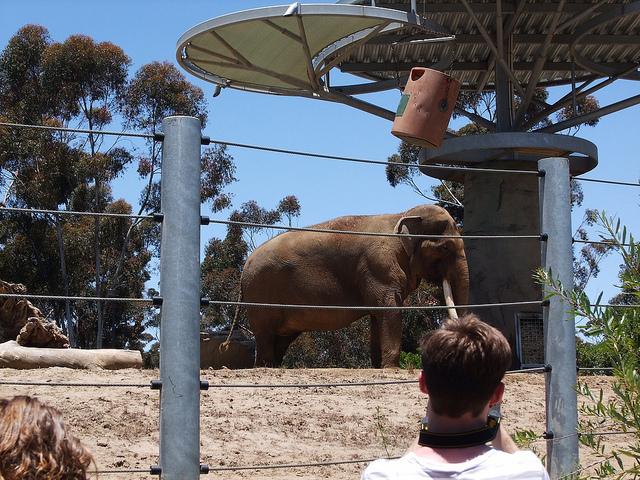What is the name of the animal?
Concise answer only. Elephant. What type of fence is that?
Short answer required. Wire. What is the contraption on the right?
Short answer required. Feeder. Does that look like a secure fence?
Concise answer only. Yes. 